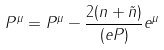Convert formula to latex. <formula><loc_0><loc_0><loc_500><loc_500>P ^ { \mu } = P ^ { \mu } - \frac { 2 ( n + \tilde { n } ) } { ( e P ) } e ^ { \mu }</formula> 